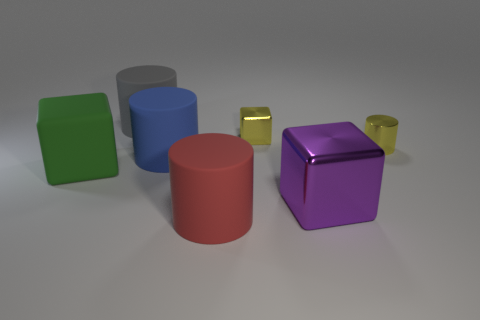Is the color of the tiny cylinder the same as the small cube?
Keep it short and to the point. Yes. There is a object that is both in front of the large green block and on the right side of the tiny metal cube; what is its shape?
Provide a short and direct response. Cube. What number of small yellow things are the same shape as the big red matte object?
Give a very brief answer. 1. How many big things are there?
Ensure brevity in your answer.  5. What size is the matte thing that is both in front of the blue rubber thing and on the left side of the blue rubber cylinder?
Offer a very short reply. Large. There is a gray thing that is the same size as the purple metallic thing; what is its shape?
Your answer should be very brief. Cylinder. There is a big object behind the tiny yellow shiny cylinder; are there any red cylinders that are behind it?
Keep it short and to the point. No. What is the color of the other tiny shiny object that is the same shape as the gray thing?
Your response must be concise. Yellow. There is a big rubber cylinder behind the yellow shiny block; is its color the same as the tiny metallic block?
Ensure brevity in your answer.  No. How many objects are either purple shiny objects that are in front of the gray object or red cylinders?
Give a very brief answer. 2. 